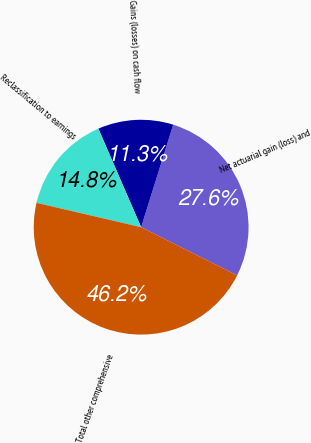<chart> <loc_0><loc_0><loc_500><loc_500><pie_chart><fcel>Net actuarial gain (loss) and<fcel>Gains (losses) on cash flow<fcel>Reclassification to earnings<fcel>Total other comprehensive<nl><fcel>27.57%<fcel>11.35%<fcel>14.84%<fcel>46.25%<nl></chart> 